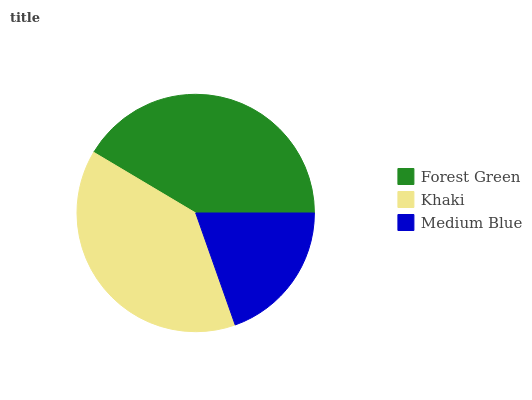Is Medium Blue the minimum?
Answer yes or no. Yes. Is Forest Green the maximum?
Answer yes or no. Yes. Is Khaki the minimum?
Answer yes or no. No. Is Khaki the maximum?
Answer yes or no. No. Is Forest Green greater than Khaki?
Answer yes or no. Yes. Is Khaki less than Forest Green?
Answer yes or no. Yes. Is Khaki greater than Forest Green?
Answer yes or no. No. Is Forest Green less than Khaki?
Answer yes or no. No. Is Khaki the high median?
Answer yes or no. Yes. Is Khaki the low median?
Answer yes or no. Yes. Is Medium Blue the high median?
Answer yes or no. No. Is Medium Blue the low median?
Answer yes or no. No. 